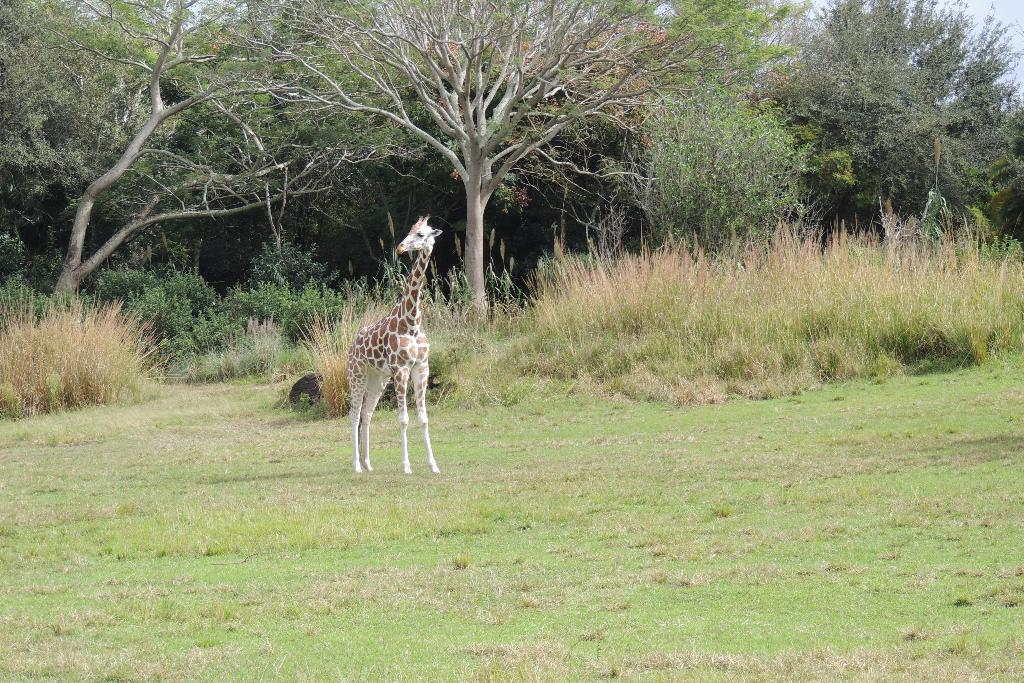What type of animal can be seen in the picture? There is a giraffe in the picture. What other elements are present in the picture besides the giraffe? There are plants and trees in the picture. What can be seen in the background of the picture? The sky is visible in the background of the picture. What type of rose can be seen in the frame of the picture? There is no rose present in the image. 